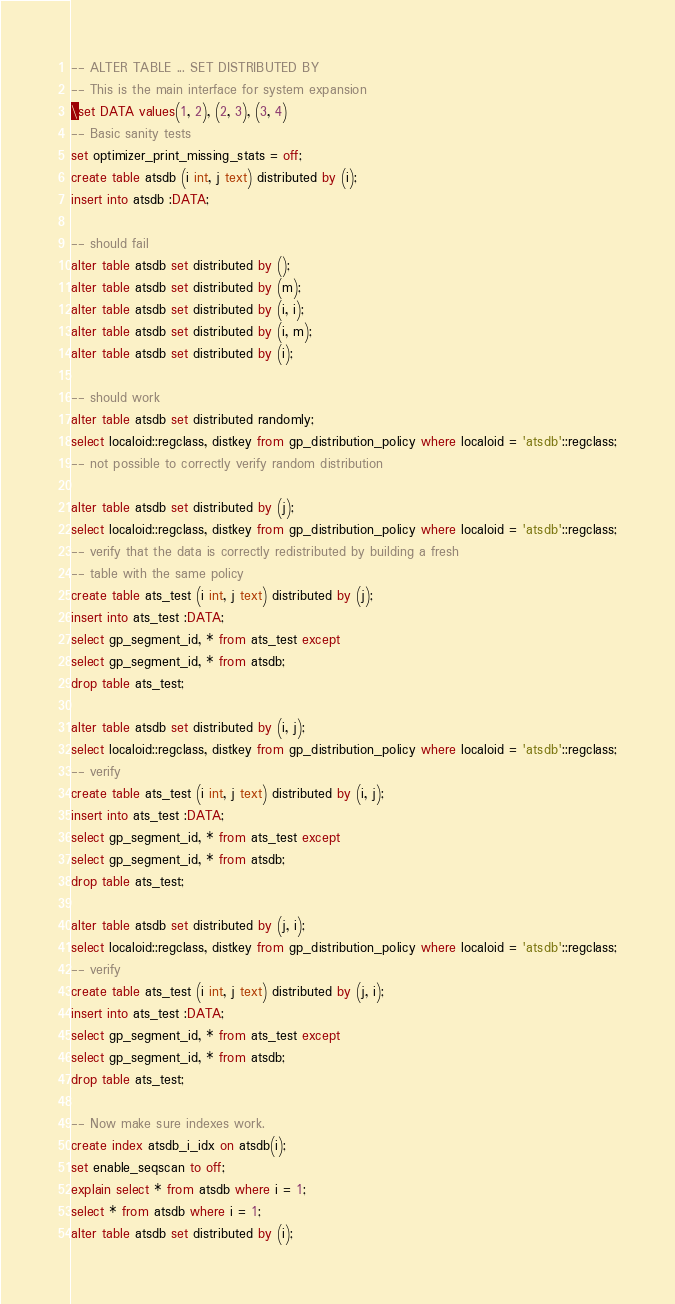Convert code to text. <code><loc_0><loc_0><loc_500><loc_500><_SQL_>-- ALTER TABLE ... SET DISTRIBUTED BY
-- This is the main interface for system expansion
\set DATA values(1, 2), (2, 3), (3, 4)
-- Basic sanity tests
set optimizer_print_missing_stats = off;
create table atsdb (i int, j text) distributed by (i);
insert into atsdb :DATA;

-- should fail
alter table atsdb set distributed by ();
alter table atsdb set distributed by (m);
alter table atsdb set distributed by (i, i);
alter table atsdb set distributed by (i, m);
alter table atsdb set distributed by (i);

-- should work
alter table atsdb set distributed randomly;
select localoid::regclass, distkey from gp_distribution_policy where localoid = 'atsdb'::regclass;
-- not possible to correctly verify random distribution

alter table atsdb set distributed by (j);
select localoid::regclass, distkey from gp_distribution_policy where localoid = 'atsdb'::regclass;
-- verify that the data is correctly redistributed by building a fresh
-- table with the same policy
create table ats_test (i int, j text) distributed by (j);
insert into ats_test :DATA;
select gp_segment_id, * from ats_test except
select gp_segment_id, * from atsdb;
drop table ats_test;

alter table atsdb set distributed by (i, j);
select localoid::regclass, distkey from gp_distribution_policy where localoid = 'atsdb'::regclass;
-- verify
create table ats_test (i int, j text) distributed by (i, j);
insert into ats_test :DATA;
select gp_segment_id, * from ats_test except
select gp_segment_id, * from atsdb;
drop table ats_test;

alter table atsdb set distributed by (j, i);
select localoid::regclass, distkey from gp_distribution_policy where localoid = 'atsdb'::regclass;
-- verify
create table ats_test (i int, j text) distributed by (j, i);
insert into ats_test :DATA;
select gp_segment_id, * from ats_test except
select gp_segment_id, * from atsdb;
drop table ats_test;

-- Now make sure indexes work.
create index atsdb_i_idx on atsdb(i);
set enable_seqscan to off;
explain select * from atsdb where i = 1;
select * from atsdb where i = 1;
alter table atsdb set distributed by (i);</code> 